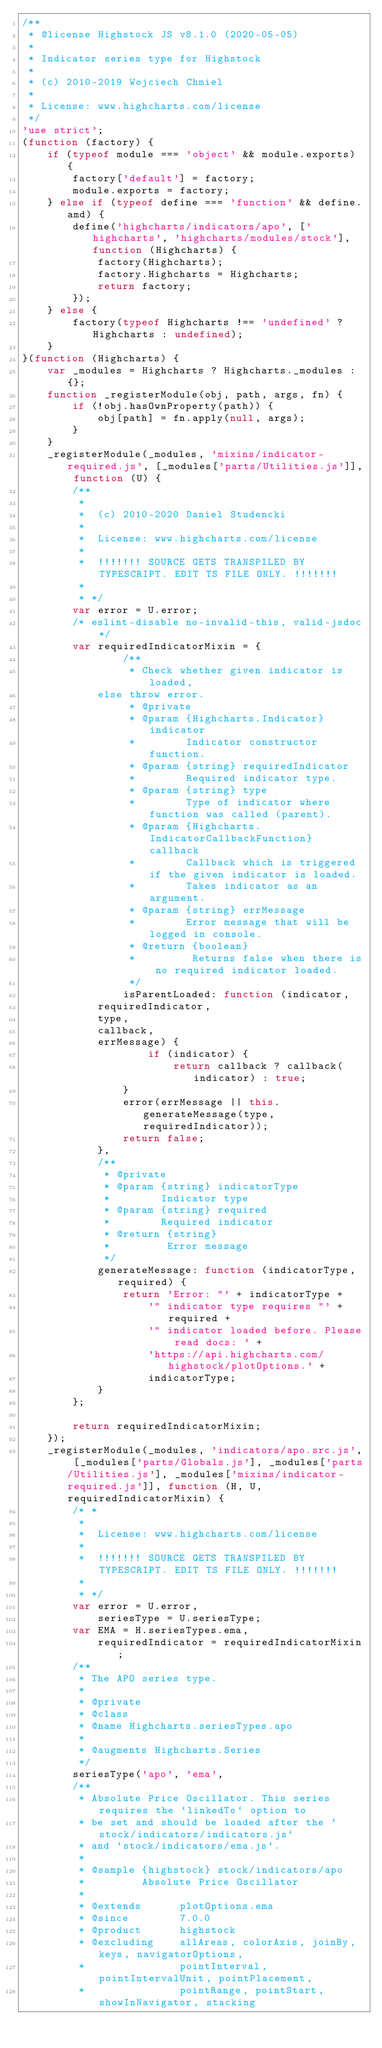Convert code to text. <code><loc_0><loc_0><loc_500><loc_500><_JavaScript_>/**
 * @license Highstock JS v8.1.0 (2020-05-05)
 *
 * Indicator series type for Highstock
 *
 * (c) 2010-2019 Wojciech Chmiel
 *
 * License: www.highcharts.com/license
 */
'use strict';
(function (factory) {
    if (typeof module === 'object' && module.exports) {
        factory['default'] = factory;
        module.exports = factory;
    } else if (typeof define === 'function' && define.amd) {
        define('highcharts/indicators/apo', ['highcharts', 'highcharts/modules/stock'], function (Highcharts) {
            factory(Highcharts);
            factory.Highcharts = Highcharts;
            return factory;
        });
    } else {
        factory(typeof Highcharts !== 'undefined' ? Highcharts : undefined);
    }
}(function (Highcharts) {
    var _modules = Highcharts ? Highcharts._modules : {};
    function _registerModule(obj, path, args, fn) {
        if (!obj.hasOwnProperty(path)) {
            obj[path] = fn.apply(null, args);
        }
    }
    _registerModule(_modules, 'mixins/indicator-required.js', [_modules['parts/Utilities.js']], function (U) {
        /**
         *
         *  (c) 2010-2020 Daniel Studencki
         *
         *  License: www.highcharts.com/license
         *
         *  !!!!!!! SOURCE GETS TRANSPILED BY TYPESCRIPT. EDIT TS FILE ONLY. !!!!!!!
         *
         * */
        var error = U.error;
        /* eslint-disable no-invalid-this, valid-jsdoc */
        var requiredIndicatorMixin = {
                /**
                 * Check whether given indicator is loaded,
            else throw error.
                 * @private
                 * @param {Highcharts.Indicator} indicator
                 *        Indicator constructor function.
                 * @param {string} requiredIndicator
                 *        Required indicator type.
                 * @param {string} type
                 *        Type of indicator where function was called (parent).
                 * @param {Highcharts.IndicatorCallbackFunction} callback
                 *        Callback which is triggered if the given indicator is loaded.
                 *        Takes indicator as an argument.
                 * @param {string} errMessage
                 *        Error message that will be logged in console.
                 * @return {boolean}
                 *         Returns false when there is no required indicator loaded.
                 */
                isParentLoaded: function (indicator,
            requiredIndicator,
            type,
            callback,
            errMessage) {
                    if (indicator) {
                        return callback ? callback(indicator) : true;
                }
                error(errMessage || this.generateMessage(type, requiredIndicator));
                return false;
            },
            /**
             * @private
             * @param {string} indicatorType
             *        Indicator type
             * @param {string} required
             *        Required indicator
             * @return {string}
             *         Error message
             */
            generateMessage: function (indicatorType, required) {
                return 'Error: "' + indicatorType +
                    '" indicator type requires "' + required +
                    '" indicator loaded before. Please read docs: ' +
                    'https://api.highcharts.com/highstock/plotOptions.' +
                    indicatorType;
            }
        };

        return requiredIndicatorMixin;
    });
    _registerModule(_modules, 'indicators/apo.src.js', [_modules['parts/Globals.js'], _modules['parts/Utilities.js'], _modules['mixins/indicator-required.js']], function (H, U, requiredIndicatorMixin) {
        /* *
         *
         *  License: www.highcharts.com/license
         *
         *  !!!!!!! SOURCE GETS TRANSPILED BY TYPESCRIPT. EDIT TS FILE ONLY. !!!!!!!
         *
         * */
        var error = U.error,
            seriesType = U.seriesType;
        var EMA = H.seriesTypes.ema,
            requiredIndicator = requiredIndicatorMixin;
        /**
         * The APO series type.
         *
         * @private
         * @class
         * @name Highcharts.seriesTypes.apo
         *
         * @augments Highcharts.Series
         */
        seriesType('apo', 'ema', 
        /**
         * Absolute Price Oscillator. This series requires the `linkedTo` option to
         * be set and should be loaded after the `stock/indicators/indicators.js`
         * and `stock/indicators/ema.js`.
         *
         * @sample {highstock} stock/indicators/apo
         *         Absolute Price Oscillator
         *
         * @extends      plotOptions.ema
         * @since        7.0.0
         * @product      highstock
         * @excluding    allAreas, colorAxis, joinBy, keys, navigatorOptions,
         *               pointInterval, pointIntervalUnit, pointPlacement,
         *               pointRange, pointStart, showInNavigator, stacking</code> 